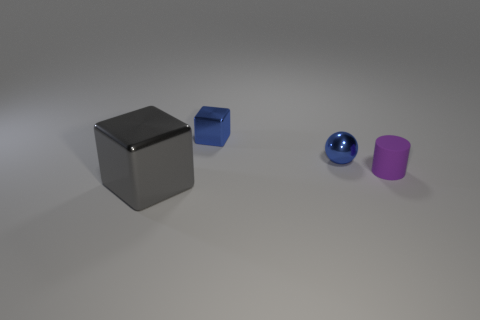Is there a tiny matte cylinder to the right of the metal cube behind the large gray shiny object?
Your answer should be very brief. Yes. What number of blue cylinders are there?
Your answer should be very brief. 0. There is a big metal block; does it have the same color as the block behind the small purple cylinder?
Ensure brevity in your answer.  No. Are there more large gray things than large yellow rubber cylinders?
Keep it short and to the point. Yes. Is there any other thing of the same color as the cylinder?
Provide a short and direct response. No. How many other objects are the same size as the blue block?
Keep it short and to the point. 2. What material is the cube that is on the right side of the thing that is to the left of the cube behind the rubber object?
Your answer should be compact. Metal. Does the gray thing have the same material as the small blue thing on the right side of the small blue shiny block?
Offer a very short reply. Yes. Are there fewer large metallic things left of the large shiny thing than tiny blue metal things that are on the left side of the purple cylinder?
Offer a very short reply. Yes. How many other cylinders are made of the same material as the small purple cylinder?
Your answer should be very brief. 0. 